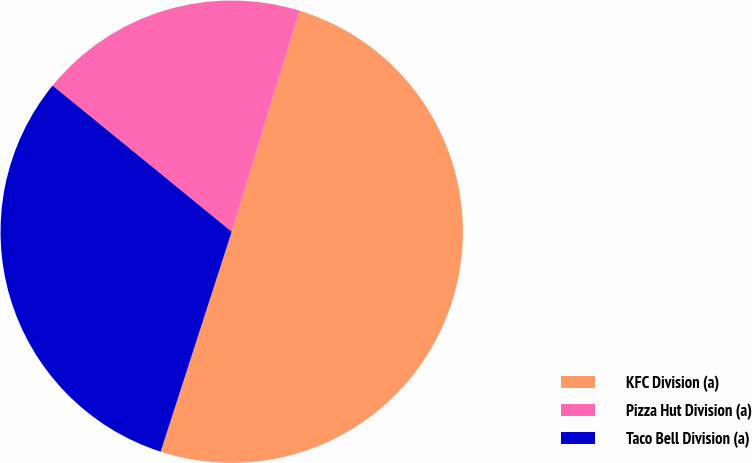Convert chart. <chart><loc_0><loc_0><loc_500><loc_500><pie_chart><fcel>KFC Division (a)<fcel>Pizza Hut Division (a)<fcel>Taco Bell Division (a)<nl><fcel>50.23%<fcel>18.85%<fcel>30.92%<nl></chart> 